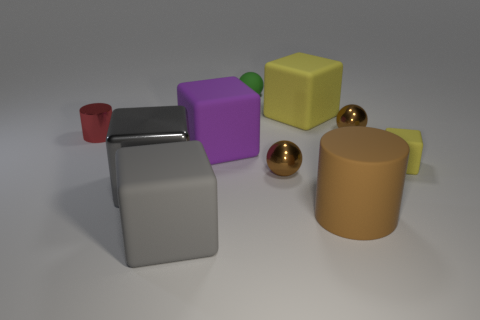Is the color of the big shiny block the same as the big block in front of the big shiny thing? yes 